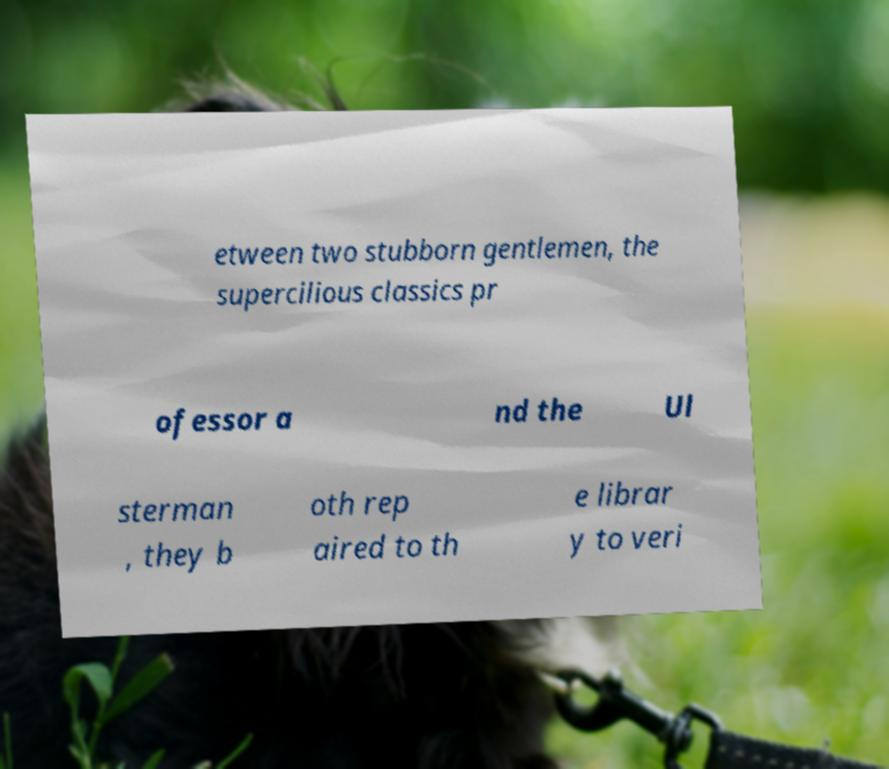There's text embedded in this image that I need extracted. Can you transcribe it verbatim? etween two stubborn gentlemen, the supercilious classics pr ofessor a nd the Ul sterman , they b oth rep aired to th e librar y to veri 